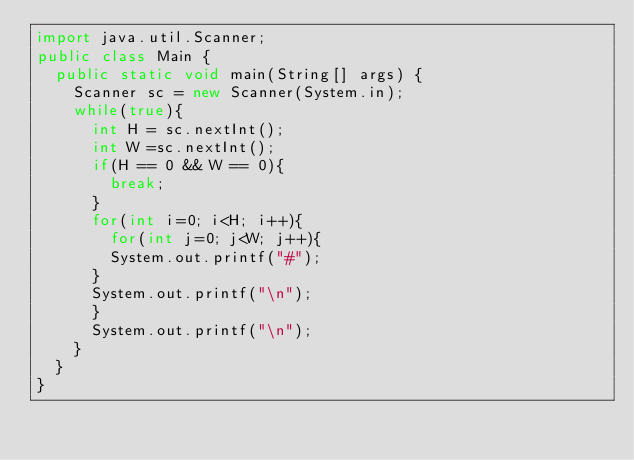<code> <loc_0><loc_0><loc_500><loc_500><_Java_>import java.util.Scanner;
public class Main { 
	public static void main(String[] args) { 
		Scanner sc = new Scanner(System.in);
		while(true){
			int H = sc.nextInt();
			int W =sc.nextInt();
			if(H == 0 && W == 0){
				break;
			}
			for(int i=0; i<H; i++){
				for(int j=0; j<W; j++){
				System.out.printf("#");
			}
			System.out.printf("\n");
			}
			System.out.printf("\n");
		}
	}
}</code> 